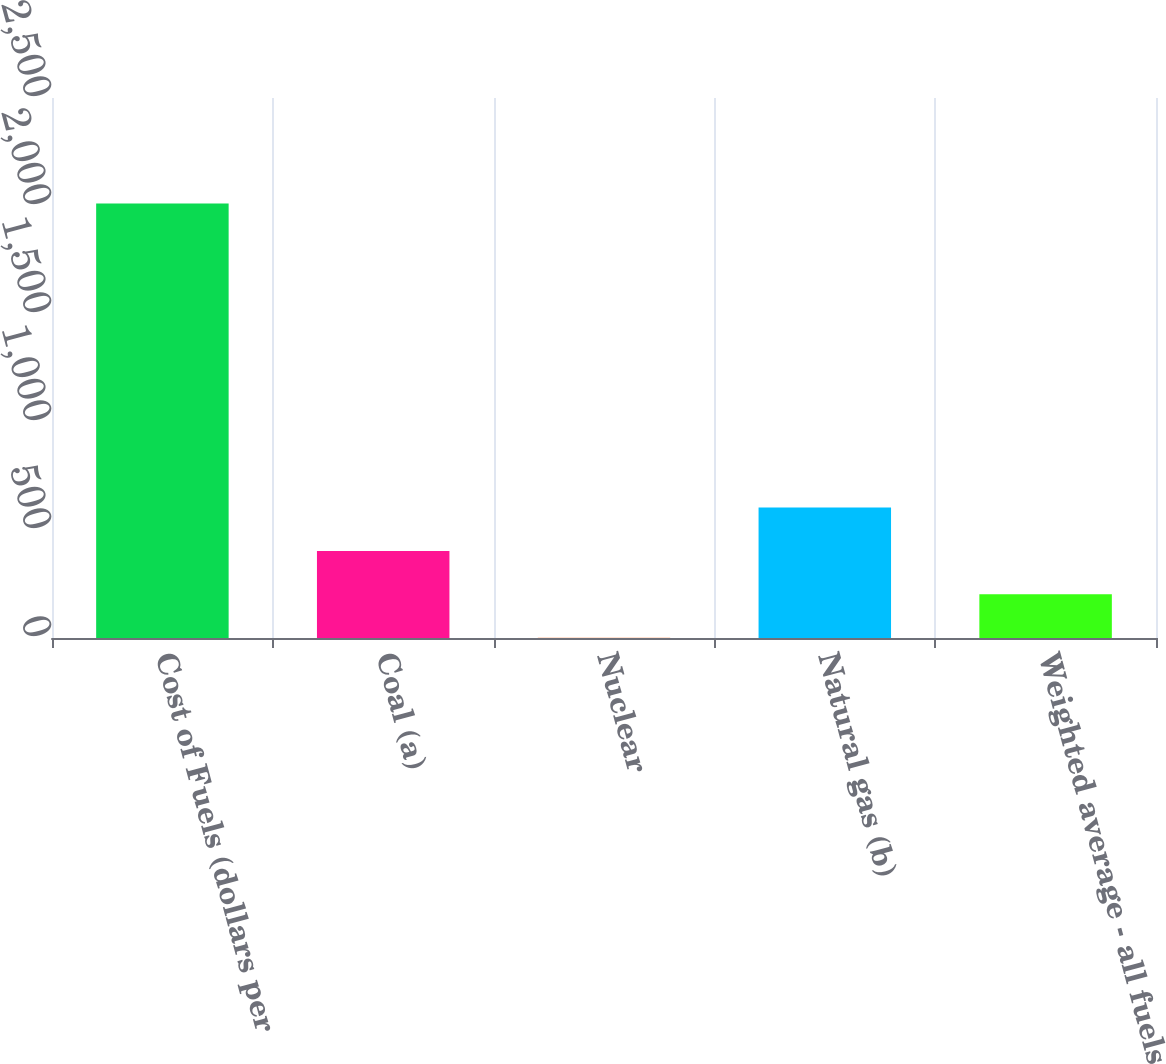<chart> <loc_0><loc_0><loc_500><loc_500><bar_chart><fcel>Cost of Fuels (dollars per<fcel>Coal (a)<fcel>Nuclear<fcel>Natural gas (b)<fcel>Weighted average - all fuels<nl><fcel>2012<fcel>403.16<fcel>0.96<fcel>604.26<fcel>202.06<nl></chart> 